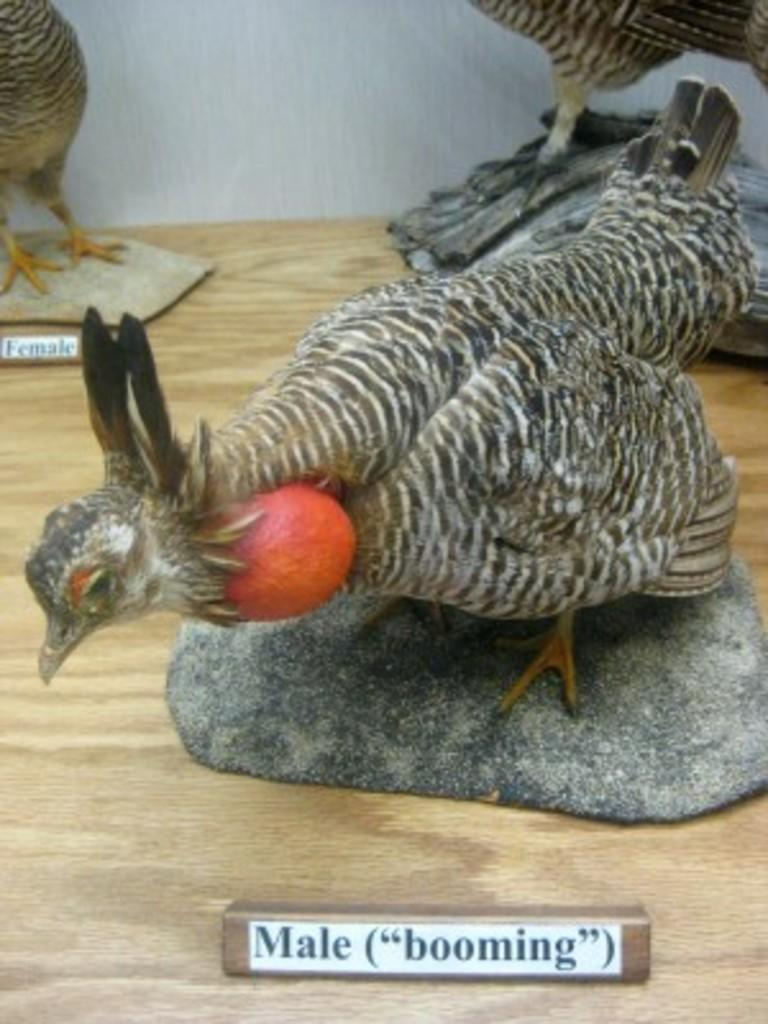What type of objects are depicted in the image? There are statues of birds in the image. How can the statues be identified? The statues have name plates. What material is the surface on which the statues are placed? The statues are placed on a wooden surface. What is the income of the goat depicted in the image? There is no goat present in the image, so it is not possible to determine its income. 